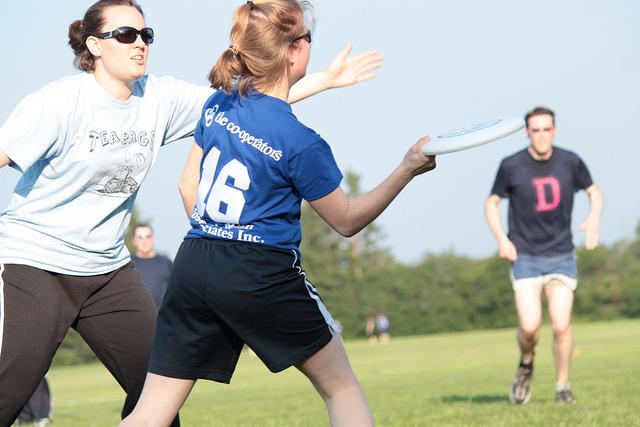What sport are the people playing?
Quick response, please. Frisbee. Who has the frisbee?
Be succinct. Girl. What color is the woman's shirt on the left?
Concise answer only. White. Is the number '15' in the photo?
Keep it brief. No. What color is the man on right's shirt?
Write a very short answer. Black. Are these women experienced in frisbee?
Give a very brief answer. Yes. Is the main girl in the image wearing any socks?
Keep it brief. Yes. How many people are wearing shorts?
Be succinct. 2. 